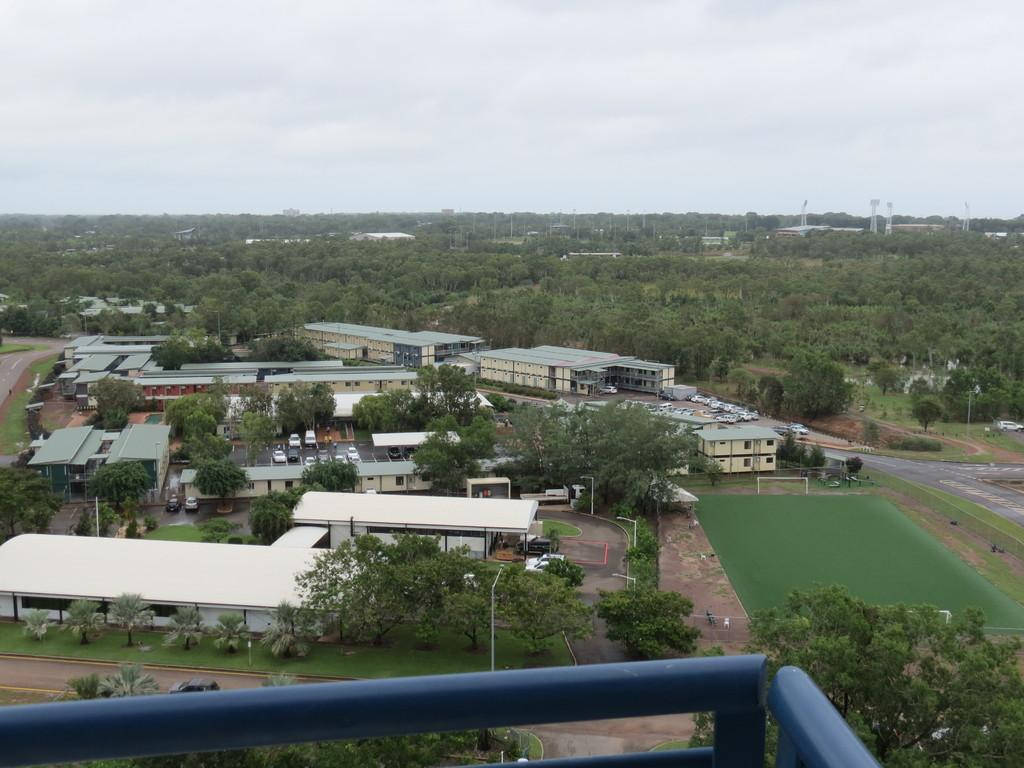What type of structures can be seen in the image? There are buildings in the image. What other natural elements are present in the image? There are trees in the image. Are there any tall structures in the image? Yes, there are towers in the image. What mode of transportation can be seen on the road in the image? There are cars on the road in the image. What recreational area is visible on the right side of the image? There is a volleyball court on the right side of the image. What is visible in the background of the image? The sky is visible in the background of the image. How many babies are crawling on the volleyball court in the image? There are no babies present on the volleyball court in the image. What type of writing instrument is being used by the trees in the image? Trees do not use writing instruments; there are no quills or any other writing instruments present in the image. 